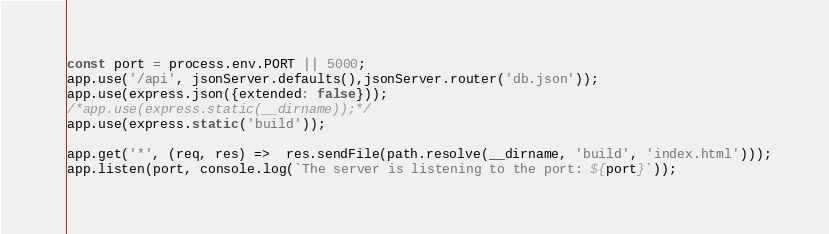<code> <loc_0><loc_0><loc_500><loc_500><_JavaScript_>const port = process.env.PORT || 5000;
app.use('/api', jsonServer.defaults(),jsonServer.router('db.json'));
app.use(express.json({extended: false}));
/*app.use(express.static(__dirname));*/
app.use(express.static('build'));

app.get('*', (req, res) =>  res.sendFile(path.resolve(__dirname, 'build', 'index.html')));
app.listen(port, console.log(`The server is listening to the port: ${port}`));
</code> 